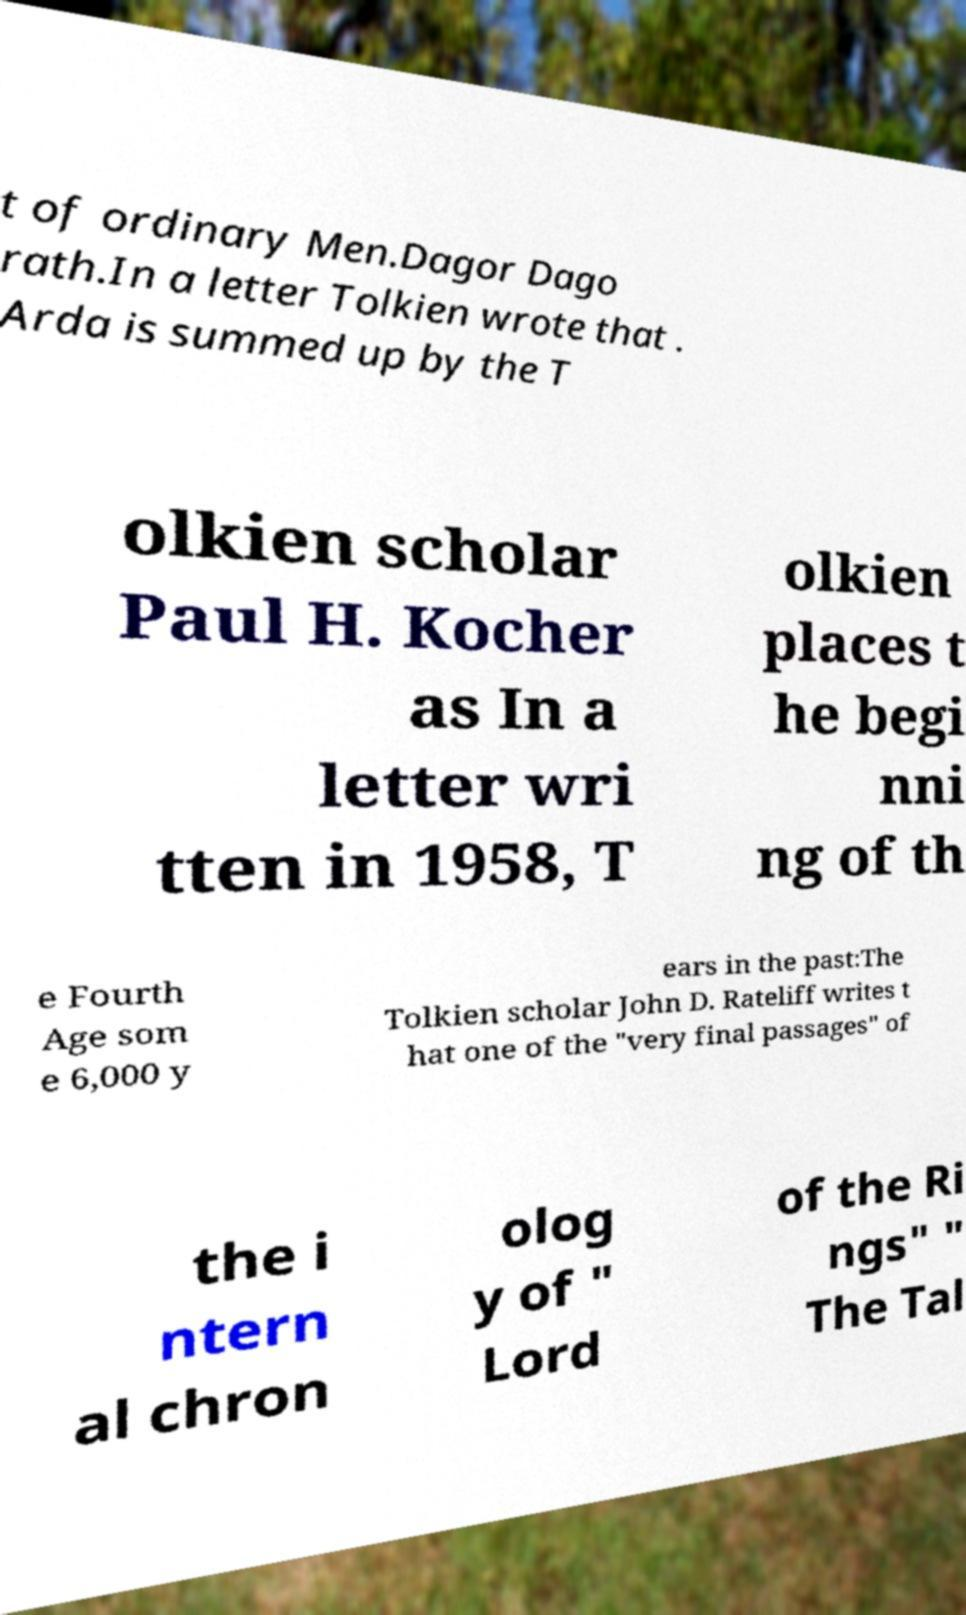What messages or text are displayed in this image? I need them in a readable, typed format. t of ordinary Men.Dagor Dago rath.In a letter Tolkien wrote that . Arda is summed up by the T olkien scholar Paul H. Kocher as In a letter wri tten in 1958, T olkien places t he begi nni ng of th e Fourth Age som e 6,000 y ears in the past:The Tolkien scholar John D. Rateliff writes t hat one of the "very final passages" of the i ntern al chron olog y of " Lord of the Ri ngs" " The Tal 